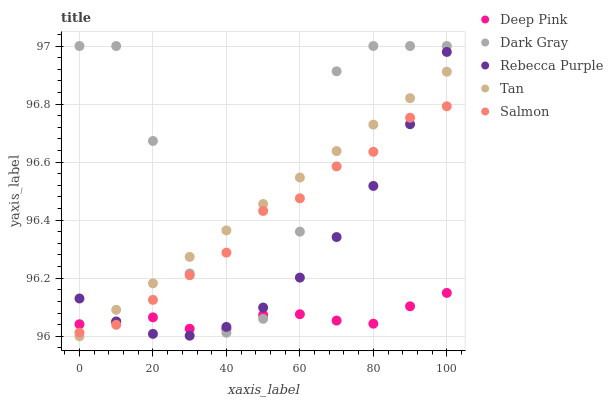Does Deep Pink have the minimum area under the curve?
Answer yes or no. Yes. Does Dark Gray have the maximum area under the curve?
Answer yes or no. Yes. Does Tan have the minimum area under the curve?
Answer yes or no. No. Does Tan have the maximum area under the curve?
Answer yes or no. No. Is Tan the smoothest?
Answer yes or no. Yes. Is Dark Gray the roughest?
Answer yes or no. Yes. Is Deep Pink the smoothest?
Answer yes or no. No. Is Deep Pink the roughest?
Answer yes or no. No. Does Tan have the lowest value?
Answer yes or no. Yes. Does Deep Pink have the lowest value?
Answer yes or no. No. Does Dark Gray have the highest value?
Answer yes or no. Yes. Does Tan have the highest value?
Answer yes or no. No. Does Salmon intersect Rebecca Purple?
Answer yes or no. Yes. Is Salmon less than Rebecca Purple?
Answer yes or no. No. Is Salmon greater than Rebecca Purple?
Answer yes or no. No. 